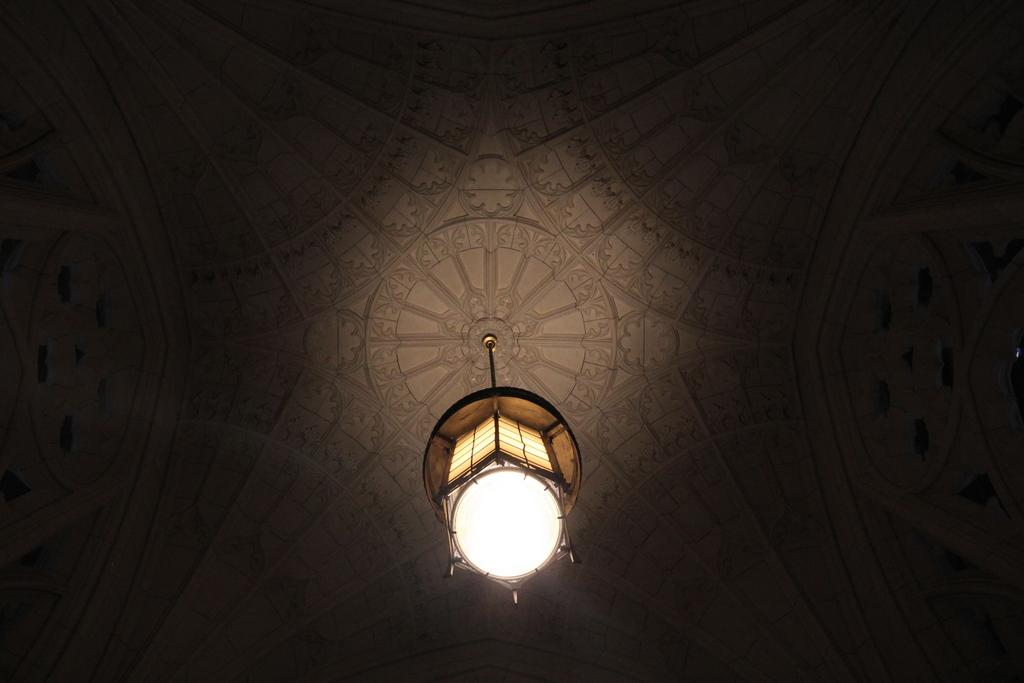What is attached to the ceiling in the image? There is a light attached to the ceiling in the image. What can be observed about the background of the image? The background of the image is dark. What type of steel material can be seen in the image? There is no steel material present in the image. What kind of hall is visible in the image? There is no hall visible in the image. 